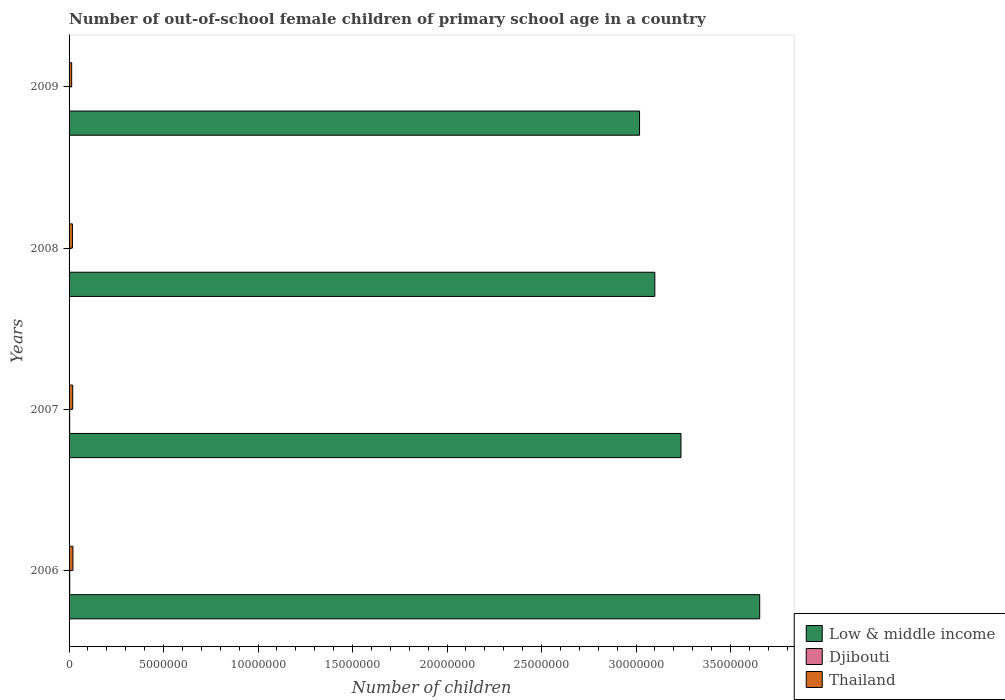How many groups of bars are there?
Make the answer very short. 4. Are the number of bars on each tick of the Y-axis equal?
Provide a short and direct response. Yes. How many bars are there on the 3rd tick from the top?
Provide a succinct answer. 3. How many bars are there on the 1st tick from the bottom?
Offer a terse response. 3. What is the number of out-of-school female children in Djibouti in 2008?
Offer a terse response. 2.31e+04. Across all years, what is the maximum number of out-of-school female children in Thailand?
Your answer should be very brief. 2.04e+05. Across all years, what is the minimum number of out-of-school female children in Djibouti?
Provide a short and direct response. 2.30e+04. In which year was the number of out-of-school female children in Low & middle income maximum?
Your answer should be compact. 2006. In which year was the number of out-of-school female children in Djibouti minimum?
Offer a very short reply. 2009. What is the total number of out-of-school female children in Thailand in the graph?
Make the answer very short. 7.12e+05. What is the difference between the number of out-of-school female children in Djibouti in 2006 and that in 2009?
Provide a succinct answer. 1.22e+04. What is the difference between the number of out-of-school female children in Thailand in 2006 and the number of out-of-school female children in Low & middle income in 2009?
Keep it short and to the point. -3.00e+07. What is the average number of out-of-school female children in Thailand per year?
Give a very brief answer. 1.78e+05. In the year 2008, what is the difference between the number of out-of-school female children in Djibouti and number of out-of-school female children in Thailand?
Your answer should be compact. -1.55e+05. In how many years, is the number of out-of-school female children in Djibouti greater than 16000000 ?
Provide a short and direct response. 0. What is the ratio of the number of out-of-school female children in Low & middle income in 2006 to that in 2008?
Offer a terse response. 1.18. Is the number of out-of-school female children in Thailand in 2006 less than that in 2008?
Offer a very short reply. No. Is the difference between the number of out-of-school female children in Djibouti in 2006 and 2007 greater than the difference between the number of out-of-school female children in Thailand in 2006 and 2007?
Make the answer very short. No. What is the difference between the highest and the second highest number of out-of-school female children in Low & middle income?
Your answer should be compact. 4.16e+06. What is the difference between the highest and the lowest number of out-of-school female children in Djibouti?
Ensure brevity in your answer.  1.22e+04. Is the sum of the number of out-of-school female children in Thailand in 2006 and 2008 greater than the maximum number of out-of-school female children in Djibouti across all years?
Make the answer very short. Yes. What does the 2nd bar from the top in 2006 represents?
Your answer should be compact. Djibouti. What does the 2nd bar from the bottom in 2009 represents?
Your response must be concise. Djibouti. How many bars are there?
Offer a very short reply. 12. Are all the bars in the graph horizontal?
Ensure brevity in your answer.  Yes. How many years are there in the graph?
Provide a short and direct response. 4. Are the values on the major ticks of X-axis written in scientific E-notation?
Ensure brevity in your answer.  No. Does the graph contain any zero values?
Offer a terse response. No. Where does the legend appear in the graph?
Offer a very short reply. Bottom right. How many legend labels are there?
Provide a short and direct response. 3. How are the legend labels stacked?
Offer a very short reply. Vertical. What is the title of the graph?
Provide a short and direct response. Number of out-of-school female children of primary school age in a country. What is the label or title of the X-axis?
Your answer should be very brief. Number of children. What is the label or title of the Y-axis?
Ensure brevity in your answer.  Years. What is the Number of children of Low & middle income in 2006?
Offer a very short reply. 3.65e+07. What is the Number of children in Djibouti in 2006?
Your response must be concise. 3.52e+04. What is the Number of children in Thailand in 2006?
Offer a terse response. 2.04e+05. What is the Number of children in Low & middle income in 2007?
Provide a short and direct response. 3.24e+07. What is the Number of children of Djibouti in 2007?
Provide a short and direct response. 3.15e+04. What is the Number of children in Thailand in 2007?
Provide a succinct answer. 1.92e+05. What is the Number of children of Low & middle income in 2008?
Your answer should be compact. 3.10e+07. What is the Number of children in Djibouti in 2008?
Your response must be concise. 2.31e+04. What is the Number of children in Thailand in 2008?
Make the answer very short. 1.78e+05. What is the Number of children in Low & middle income in 2009?
Your answer should be compact. 3.02e+07. What is the Number of children of Djibouti in 2009?
Give a very brief answer. 2.30e+04. What is the Number of children in Thailand in 2009?
Your response must be concise. 1.37e+05. Across all years, what is the maximum Number of children in Low & middle income?
Offer a very short reply. 3.65e+07. Across all years, what is the maximum Number of children of Djibouti?
Your response must be concise. 3.52e+04. Across all years, what is the maximum Number of children of Thailand?
Provide a succinct answer. 2.04e+05. Across all years, what is the minimum Number of children of Low & middle income?
Ensure brevity in your answer.  3.02e+07. Across all years, what is the minimum Number of children of Djibouti?
Offer a very short reply. 2.30e+04. Across all years, what is the minimum Number of children in Thailand?
Give a very brief answer. 1.37e+05. What is the total Number of children of Low & middle income in the graph?
Offer a very short reply. 1.30e+08. What is the total Number of children in Djibouti in the graph?
Give a very brief answer. 1.13e+05. What is the total Number of children in Thailand in the graph?
Your response must be concise. 7.12e+05. What is the difference between the Number of children of Low & middle income in 2006 and that in 2007?
Ensure brevity in your answer.  4.16e+06. What is the difference between the Number of children in Djibouti in 2006 and that in 2007?
Keep it short and to the point. 3665. What is the difference between the Number of children of Thailand in 2006 and that in 2007?
Keep it short and to the point. 1.18e+04. What is the difference between the Number of children of Low & middle income in 2006 and that in 2008?
Provide a short and direct response. 5.55e+06. What is the difference between the Number of children of Djibouti in 2006 and that in 2008?
Your answer should be very brief. 1.21e+04. What is the difference between the Number of children in Thailand in 2006 and that in 2008?
Your response must be concise. 2.61e+04. What is the difference between the Number of children in Low & middle income in 2006 and that in 2009?
Offer a terse response. 6.36e+06. What is the difference between the Number of children in Djibouti in 2006 and that in 2009?
Keep it short and to the point. 1.22e+04. What is the difference between the Number of children of Thailand in 2006 and that in 2009?
Your answer should be compact. 6.67e+04. What is the difference between the Number of children of Low & middle income in 2007 and that in 2008?
Offer a very short reply. 1.38e+06. What is the difference between the Number of children in Djibouti in 2007 and that in 2008?
Provide a short and direct response. 8406. What is the difference between the Number of children in Thailand in 2007 and that in 2008?
Ensure brevity in your answer.  1.43e+04. What is the difference between the Number of children of Low & middle income in 2007 and that in 2009?
Your answer should be compact. 2.19e+06. What is the difference between the Number of children in Djibouti in 2007 and that in 2009?
Your answer should be compact. 8508. What is the difference between the Number of children of Thailand in 2007 and that in 2009?
Provide a succinct answer. 5.50e+04. What is the difference between the Number of children in Low & middle income in 2008 and that in 2009?
Your answer should be compact. 8.09e+05. What is the difference between the Number of children of Djibouti in 2008 and that in 2009?
Offer a very short reply. 102. What is the difference between the Number of children of Thailand in 2008 and that in 2009?
Give a very brief answer. 4.07e+04. What is the difference between the Number of children in Low & middle income in 2006 and the Number of children in Djibouti in 2007?
Your response must be concise. 3.65e+07. What is the difference between the Number of children of Low & middle income in 2006 and the Number of children of Thailand in 2007?
Offer a very short reply. 3.64e+07. What is the difference between the Number of children of Djibouti in 2006 and the Number of children of Thailand in 2007?
Make the answer very short. -1.57e+05. What is the difference between the Number of children of Low & middle income in 2006 and the Number of children of Djibouti in 2008?
Offer a terse response. 3.65e+07. What is the difference between the Number of children in Low & middle income in 2006 and the Number of children in Thailand in 2008?
Your answer should be compact. 3.64e+07. What is the difference between the Number of children in Djibouti in 2006 and the Number of children in Thailand in 2008?
Provide a short and direct response. -1.43e+05. What is the difference between the Number of children of Low & middle income in 2006 and the Number of children of Djibouti in 2009?
Offer a terse response. 3.65e+07. What is the difference between the Number of children of Low & middle income in 2006 and the Number of children of Thailand in 2009?
Your answer should be compact. 3.64e+07. What is the difference between the Number of children in Djibouti in 2006 and the Number of children in Thailand in 2009?
Give a very brief answer. -1.02e+05. What is the difference between the Number of children in Low & middle income in 2007 and the Number of children in Djibouti in 2008?
Provide a succinct answer. 3.24e+07. What is the difference between the Number of children of Low & middle income in 2007 and the Number of children of Thailand in 2008?
Offer a very short reply. 3.22e+07. What is the difference between the Number of children of Djibouti in 2007 and the Number of children of Thailand in 2008?
Make the answer very short. -1.46e+05. What is the difference between the Number of children of Low & middle income in 2007 and the Number of children of Djibouti in 2009?
Provide a short and direct response. 3.24e+07. What is the difference between the Number of children of Low & middle income in 2007 and the Number of children of Thailand in 2009?
Keep it short and to the point. 3.22e+07. What is the difference between the Number of children in Djibouti in 2007 and the Number of children in Thailand in 2009?
Make the answer very short. -1.06e+05. What is the difference between the Number of children of Low & middle income in 2008 and the Number of children of Djibouti in 2009?
Offer a terse response. 3.10e+07. What is the difference between the Number of children of Low & middle income in 2008 and the Number of children of Thailand in 2009?
Offer a very short reply. 3.09e+07. What is the difference between the Number of children of Djibouti in 2008 and the Number of children of Thailand in 2009?
Your answer should be very brief. -1.14e+05. What is the average Number of children in Low & middle income per year?
Keep it short and to the point. 3.25e+07. What is the average Number of children in Djibouti per year?
Give a very brief answer. 2.82e+04. What is the average Number of children in Thailand per year?
Provide a short and direct response. 1.78e+05. In the year 2006, what is the difference between the Number of children in Low & middle income and Number of children in Djibouti?
Provide a short and direct response. 3.65e+07. In the year 2006, what is the difference between the Number of children of Low & middle income and Number of children of Thailand?
Keep it short and to the point. 3.63e+07. In the year 2006, what is the difference between the Number of children of Djibouti and Number of children of Thailand?
Provide a succinct answer. -1.69e+05. In the year 2007, what is the difference between the Number of children of Low & middle income and Number of children of Djibouti?
Your answer should be compact. 3.23e+07. In the year 2007, what is the difference between the Number of children of Low & middle income and Number of children of Thailand?
Give a very brief answer. 3.22e+07. In the year 2007, what is the difference between the Number of children in Djibouti and Number of children in Thailand?
Provide a succinct answer. -1.61e+05. In the year 2008, what is the difference between the Number of children of Low & middle income and Number of children of Djibouti?
Your answer should be compact. 3.10e+07. In the year 2008, what is the difference between the Number of children in Low & middle income and Number of children in Thailand?
Your answer should be very brief. 3.08e+07. In the year 2008, what is the difference between the Number of children of Djibouti and Number of children of Thailand?
Give a very brief answer. -1.55e+05. In the year 2009, what is the difference between the Number of children in Low & middle income and Number of children in Djibouti?
Provide a succinct answer. 3.02e+07. In the year 2009, what is the difference between the Number of children of Low & middle income and Number of children of Thailand?
Offer a very short reply. 3.01e+07. In the year 2009, what is the difference between the Number of children in Djibouti and Number of children in Thailand?
Provide a short and direct response. -1.14e+05. What is the ratio of the Number of children of Low & middle income in 2006 to that in 2007?
Provide a short and direct response. 1.13. What is the ratio of the Number of children of Djibouti in 2006 to that in 2007?
Provide a short and direct response. 1.12. What is the ratio of the Number of children in Thailand in 2006 to that in 2007?
Make the answer very short. 1.06. What is the ratio of the Number of children of Low & middle income in 2006 to that in 2008?
Provide a short and direct response. 1.18. What is the ratio of the Number of children in Djibouti in 2006 to that in 2008?
Provide a short and direct response. 1.52. What is the ratio of the Number of children in Thailand in 2006 to that in 2008?
Your answer should be compact. 1.15. What is the ratio of the Number of children of Low & middle income in 2006 to that in 2009?
Your answer should be very brief. 1.21. What is the ratio of the Number of children in Djibouti in 2006 to that in 2009?
Keep it short and to the point. 1.53. What is the ratio of the Number of children in Thailand in 2006 to that in 2009?
Your answer should be compact. 1.49. What is the ratio of the Number of children in Low & middle income in 2007 to that in 2008?
Provide a succinct answer. 1.04. What is the ratio of the Number of children in Djibouti in 2007 to that in 2008?
Your answer should be compact. 1.36. What is the ratio of the Number of children in Thailand in 2007 to that in 2008?
Your answer should be compact. 1.08. What is the ratio of the Number of children in Low & middle income in 2007 to that in 2009?
Provide a succinct answer. 1.07. What is the ratio of the Number of children of Djibouti in 2007 to that in 2009?
Your answer should be very brief. 1.37. What is the ratio of the Number of children in Thailand in 2007 to that in 2009?
Provide a short and direct response. 1.4. What is the ratio of the Number of children of Low & middle income in 2008 to that in 2009?
Offer a terse response. 1.03. What is the ratio of the Number of children of Thailand in 2008 to that in 2009?
Provide a succinct answer. 1.3. What is the difference between the highest and the second highest Number of children in Low & middle income?
Your response must be concise. 4.16e+06. What is the difference between the highest and the second highest Number of children in Djibouti?
Give a very brief answer. 3665. What is the difference between the highest and the second highest Number of children of Thailand?
Your answer should be very brief. 1.18e+04. What is the difference between the highest and the lowest Number of children in Low & middle income?
Make the answer very short. 6.36e+06. What is the difference between the highest and the lowest Number of children in Djibouti?
Offer a very short reply. 1.22e+04. What is the difference between the highest and the lowest Number of children in Thailand?
Make the answer very short. 6.67e+04. 